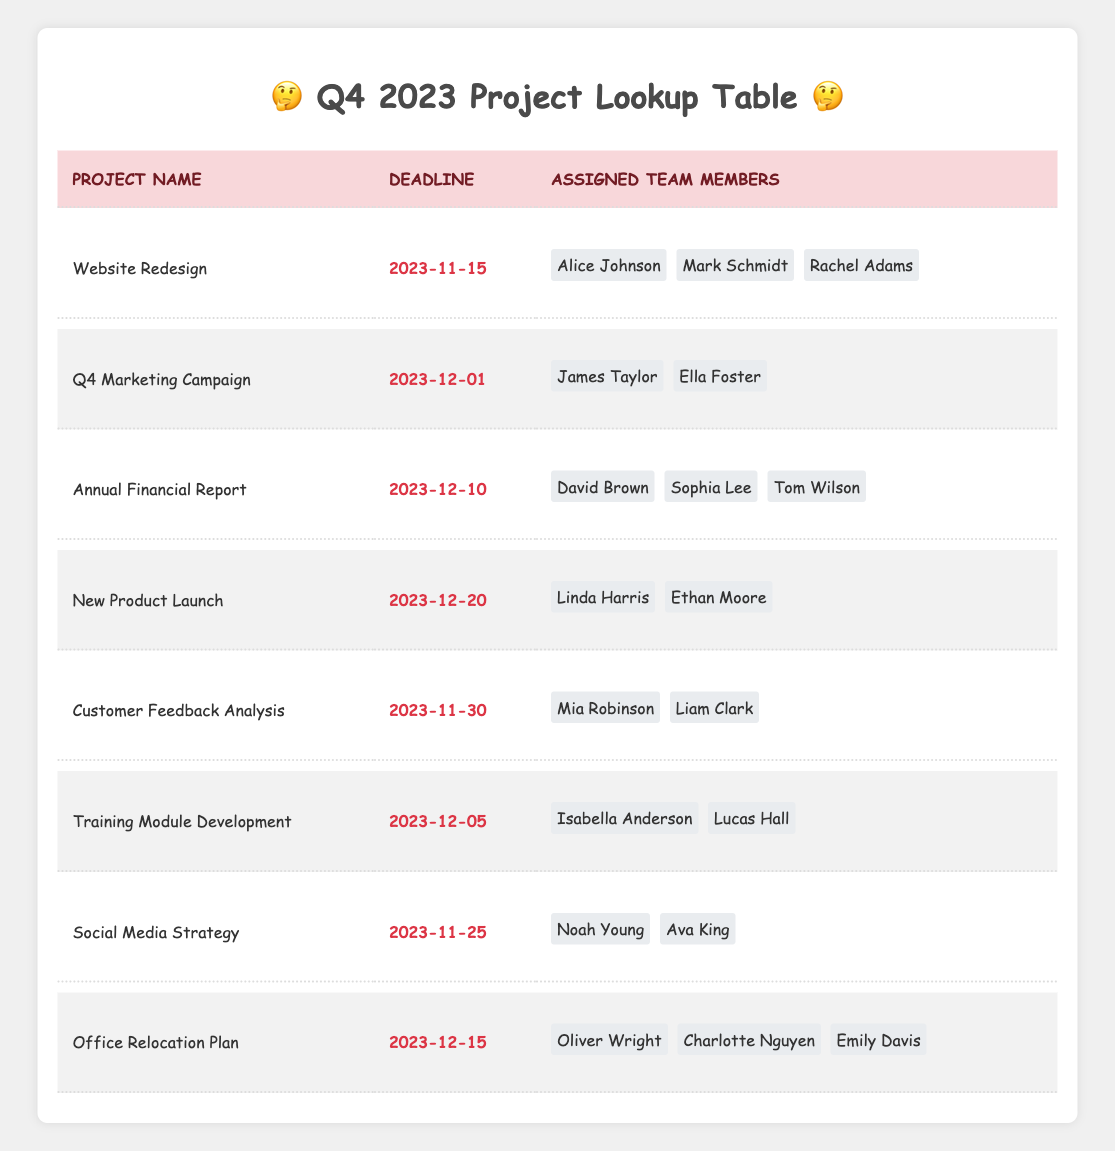What is the deadline for the "Website Redesign" project? The "Website Redesign" project has its deadline listed in the second column of the table under its project name. This is clearly stated as November 15, 2023.
Answer: November 15, 2023 Who are the assigned team members for the "Social Media Strategy" project? The team members for the "Social Media Strategy" project are found in the third column of the corresponding row. They are Noah Young and Ava King.
Answer: Noah Young, Ava King Is the "Annual Financial Report" project due before the "Customer Feedback Analysis" project? The deadlines are compared by looking at the dates in the table. The "Annual Financial Report" is due on December 10, while the "Customer Feedback Analysis" is due on November 30, so it is due first.
Answer: Yes How many team members are assigned to the "Office Relocation Plan"? To find the number of team members for the "Office Relocation Plan," we check the third column of the row for that project. There are three members listed: Oliver Wright, Charlotte Nguyen, and Emily Davis, so we count them.
Answer: 3 Which project has the latest deadline? To determine which project has the latest deadline, I compare all deadlines listed in the second column. The project "New Product Launch" has the latest deadline on December 20, 2023 because there are no other deadlines past this date.
Answer: New Product Launch How many projects are due in November? First, I check each project and its deadline listed in the table. The projects due in November are "Website Redesign," "Customer Feedback Analysis," and "Social Media Strategy." Summing these gives a total of three projects due in November.
Answer: 3 Are there more team members on the "Annual Financial Report" project than on the "Training Module Development" project? I can compare the number of team members by looking at the corresponding rows in the table. The "Annual Financial Report" has three members (David Brown, Sophia Lee, Tom Wilson) while "Training Module Development" has two (Isabella Anderson, Lucas Hall). Thus, the count for "Annual Financial Report" is greater.
Answer: Yes What is the earliest deadline among all projects? To find the earliest deadline, I review the second column of all projects and identify the date that comes first. The "Website Redesign" has a deadline of November 15, which is earlier than any other project's deadline listed.
Answer: November 15, 2023 